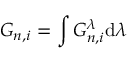Convert formula to latex. <formula><loc_0><loc_0><loc_500><loc_500>G _ { n , i } = \int G _ { n , i } ^ { \lambda } d \lambda</formula> 